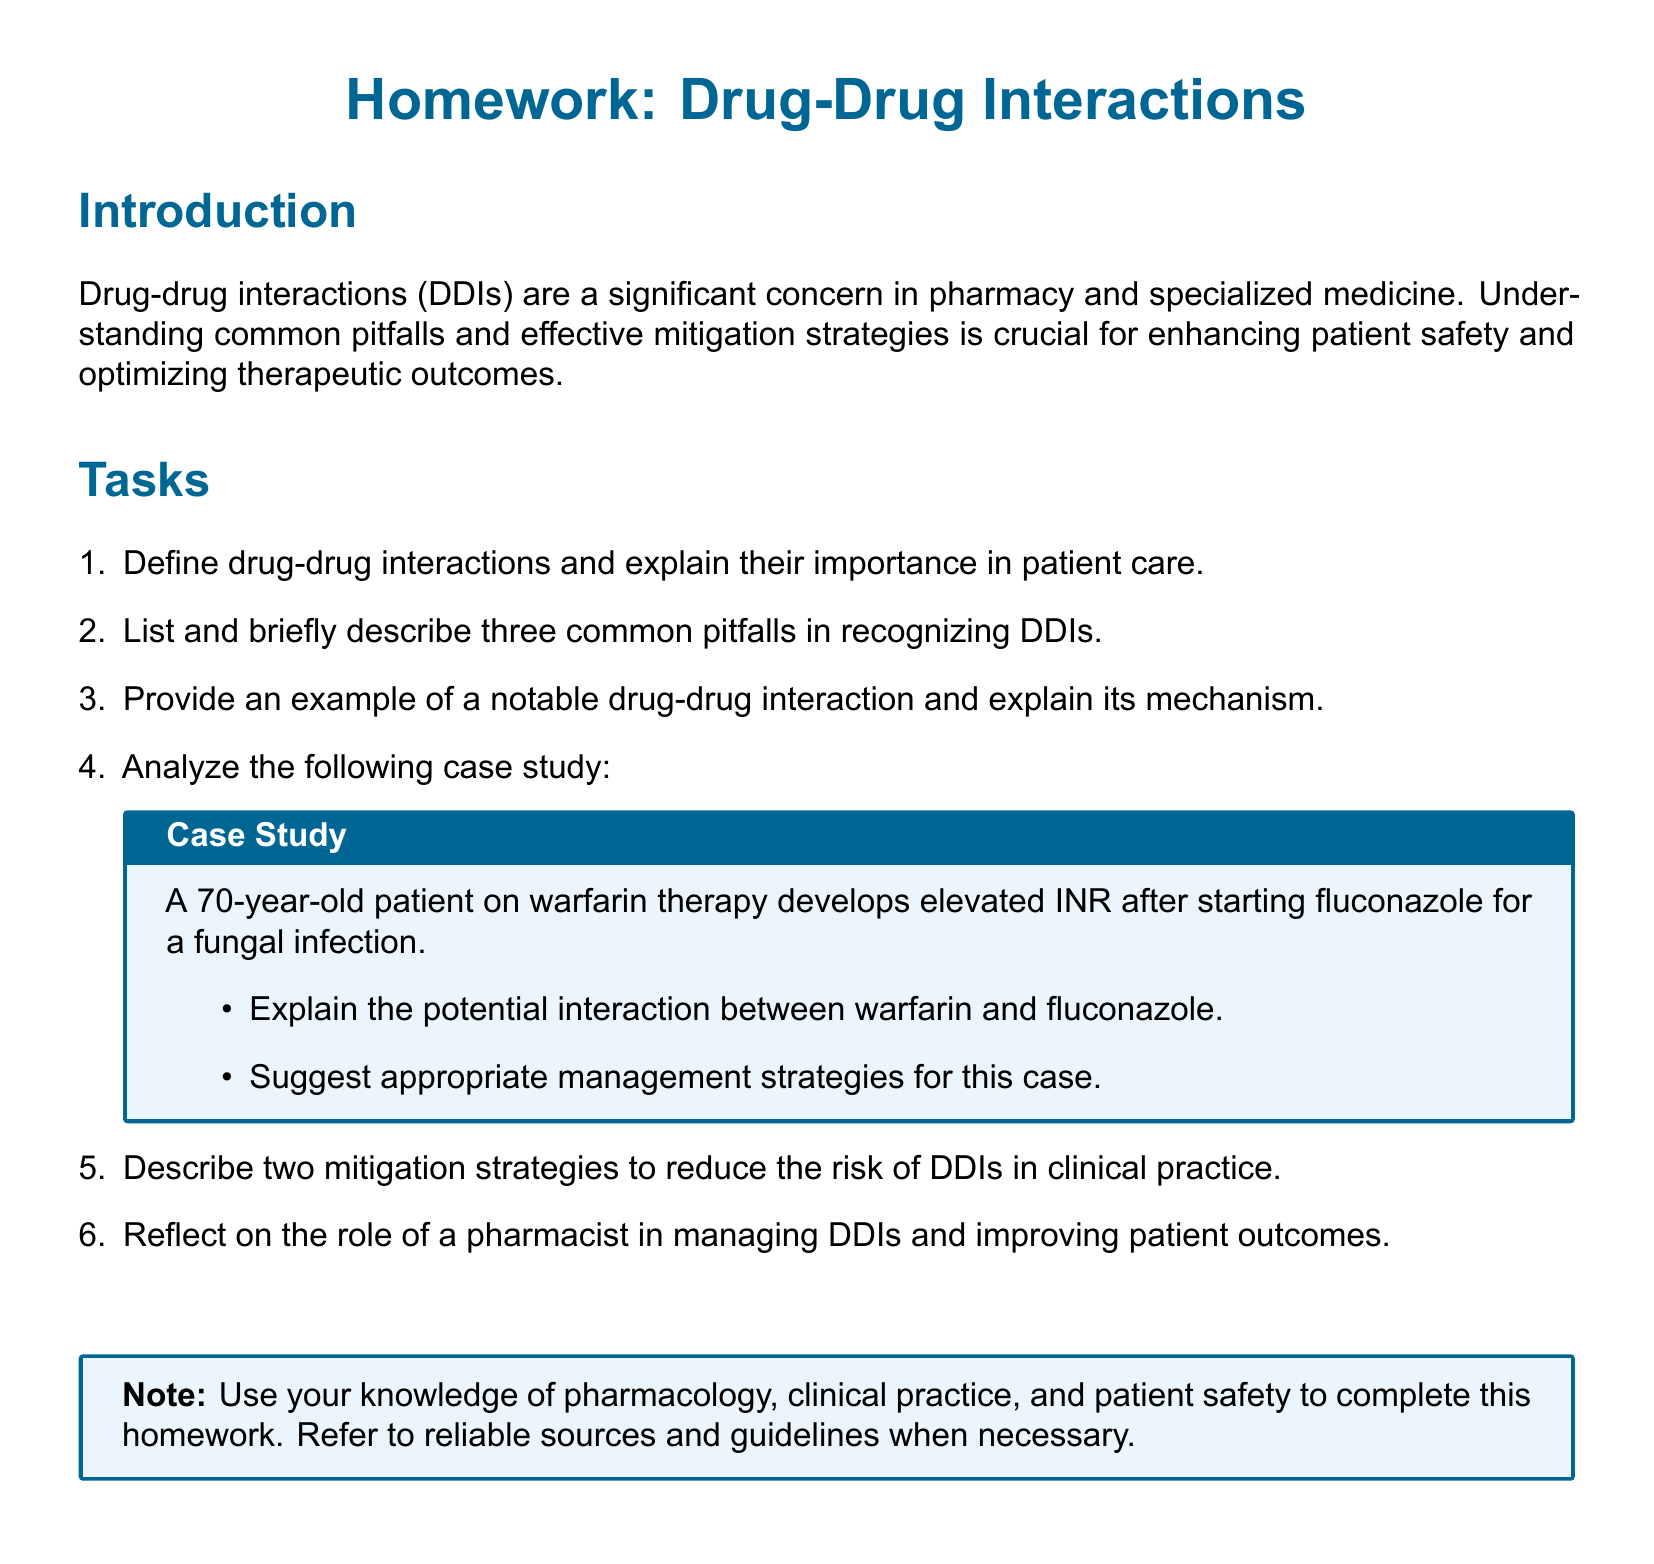what is the title of the homework? The title of the homework is presented at the top of the document.
Answer: Drug-Drug Interactions how many common pitfalls are described in section two? The document specifies the number of common pitfalls to be described in the tasks section.
Answer: Three what is an example of a case study provided? The case study involves a specific patient scenario detailed in the tasks list.
Answer: A 70-year-old patient on warfarin therapy develops elevated INR after starting fluconazole name one of the suggested management strategies for the case study. The management strategies to be suggested includes addressing the interaction between the specified drugs.
Answer: Appropriate management strategies who is responsible for improving patient outcomes in the context of DDIs? The document indicates a specific professional role responsible for managing DDIs.
Answer: Pharmacist mention one mitigation strategy for reducing the risk of DDIs. The document invites the reader to describe two specific strategies to reduce risks in practice.
Answer: Mitigation strategies what type of approach does the document encourage when completing the homework? The note in the document emphasizes the sources and guidelines the reader should refer to.
Answer: Reliable sources and guidelines 